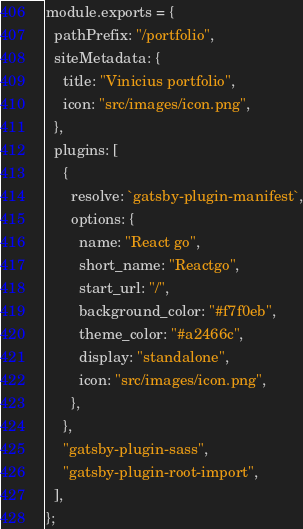<code> <loc_0><loc_0><loc_500><loc_500><_JavaScript_>module.exports = {
  pathPrefix: "/portfolio",
  siteMetadata: {
    title: "Vinicius portfolio",
    icon: "src/images/icon.png",
  },
  plugins: [
    {
      resolve: `gatsby-plugin-manifest`,
      options: {
        name: "React go",
        short_name: "Reactgo",
        start_url: "/",
        background_color: "#f7f0eb",
        theme_color: "#a2466c",
        display: "standalone",
        icon: "src/images/icon.png",
      },
    },
    "gatsby-plugin-sass",
    "gatsby-plugin-root-import",
  ],
};
</code> 